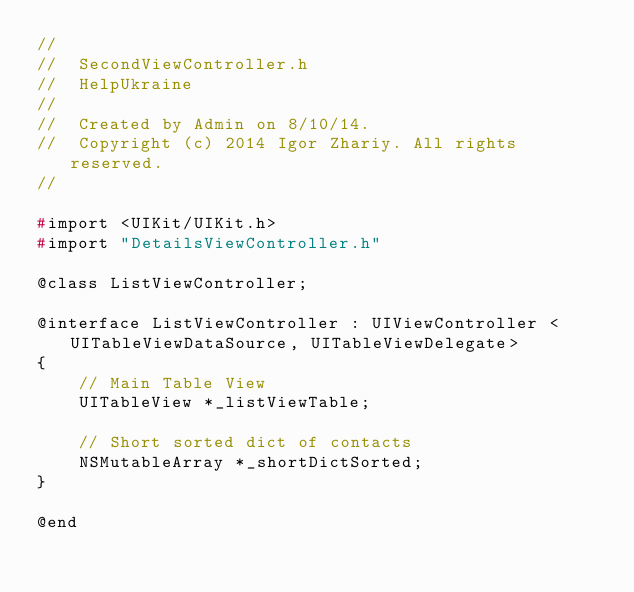Convert code to text. <code><loc_0><loc_0><loc_500><loc_500><_C_>//
//  SecondViewController.h
//  HelpUkraine
//
//  Created by Admin on 8/10/14.
//  Copyright (c) 2014 Igor Zhariy. All rights reserved.
//

#import <UIKit/UIKit.h>
#import "DetailsViewController.h"

@class ListViewController;

@interface ListViewController : UIViewController <UITableViewDataSource, UITableViewDelegate>
{
    // Main Table View
    UITableView *_listViewTable;
    
    // Short sorted dict of contacts
    NSMutableArray *_shortDictSorted;
}

@end

</code> 